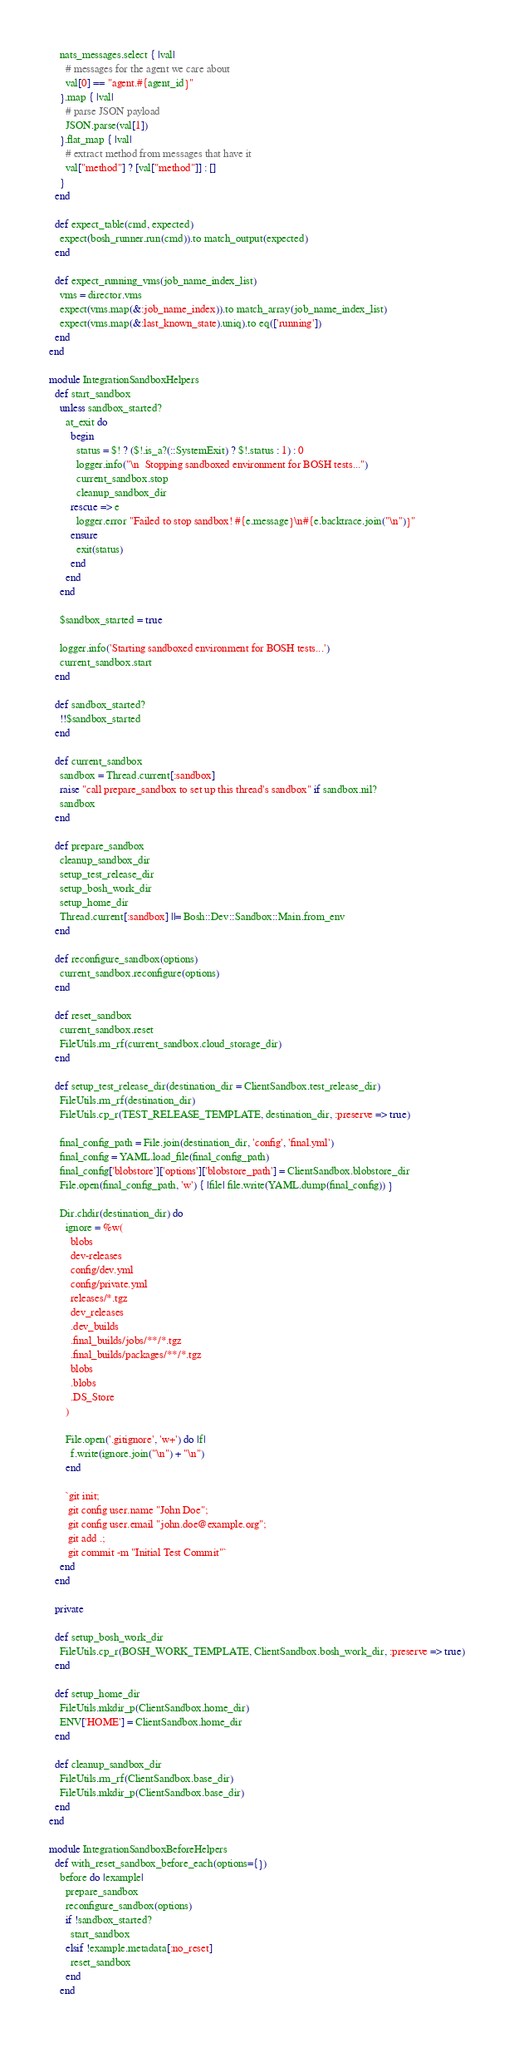Convert code to text. <code><loc_0><loc_0><loc_500><loc_500><_Ruby_>    nats_messages.select { |val|
      # messages for the agent we care about
      val[0] == "agent.#{agent_id}"
    }.map { |val|
      # parse JSON payload
      JSON.parse(val[1])
    }.flat_map { |val|
      # extract method from messages that have it
      val["method"] ? [val["method"]] : []
    }
  end

  def expect_table(cmd, expected)
    expect(bosh_runner.run(cmd)).to match_output(expected)
  end

  def expect_running_vms(job_name_index_list)
    vms = director.vms
    expect(vms.map(&:job_name_index)).to match_array(job_name_index_list)
    expect(vms.map(&:last_known_state).uniq).to eq(['running'])
  end
end

module IntegrationSandboxHelpers
  def start_sandbox
    unless sandbox_started?
      at_exit do
        begin
          status = $! ? ($!.is_a?(::SystemExit) ? $!.status : 1) : 0
          logger.info("\n  Stopping sandboxed environment for BOSH tests...")
          current_sandbox.stop
          cleanup_sandbox_dir
        rescue => e
          logger.error "Failed to stop sandbox! #{e.message}\n#{e.backtrace.join("\n")}"
        ensure
          exit(status)
        end
      end
    end

    $sandbox_started = true

    logger.info('Starting sandboxed environment for BOSH tests...')
    current_sandbox.start
  end

  def sandbox_started?
    !!$sandbox_started
  end

  def current_sandbox
    sandbox = Thread.current[:sandbox]
    raise "call prepare_sandbox to set up this thread's sandbox" if sandbox.nil?
    sandbox
  end

  def prepare_sandbox
    cleanup_sandbox_dir
    setup_test_release_dir
    setup_bosh_work_dir
    setup_home_dir
    Thread.current[:sandbox] ||= Bosh::Dev::Sandbox::Main.from_env
  end

  def reconfigure_sandbox(options)
    current_sandbox.reconfigure(options)
  end

  def reset_sandbox
    current_sandbox.reset
    FileUtils.rm_rf(current_sandbox.cloud_storage_dir)
  end

  def setup_test_release_dir(destination_dir = ClientSandbox.test_release_dir)
    FileUtils.rm_rf(destination_dir)
    FileUtils.cp_r(TEST_RELEASE_TEMPLATE, destination_dir, :preserve => true)

    final_config_path = File.join(destination_dir, 'config', 'final.yml')
    final_config = YAML.load_file(final_config_path)
    final_config['blobstore']['options']['blobstore_path'] = ClientSandbox.blobstore_dir
    File.open(final_config_path, 'w') { |file| file.write(YAML.dump(final_config)) }

    Dir.chdir(destination_dir) do
      ignore = %w(
        blobs
        dev-releases
        config/dev.yml
        config/private.yml
        releases/*.tgz
        dev_releases
        .dev_builds
        .final_builds/jobs/**/*.tgz
        .final_builds/packages/**/*.tgz
        blobs
        .blobs
        .DS_Store
      )

      File.open('.gitignore', 'w+') do |f|
        f.write(ignore.join("\n") + "\n")
      end

      `git init;
       git config user.name "John Doe";
       git config user.email "john.doe@example.org";
       git add .;
       git commit -m "Initial Test Commit"`
    end
  end

  private

  def setup_bosh_work_dir
    FileUtils.cp_r(BOSH_WORK_TEMPLATE, ClientSandbox.bosh_work_dir, :preserve => true)
  end

  def setup_home_dir
    FileUtils.mkdir_p(ClientSandbox.home_dir)
    ENV['HOME'] = ClientSandbox.home_dir
  end

  def cleanup_sandbox_dir
    FileUtils.rm_rf(ClientSandbox.base_dir)
    FileUtils.mkdir_p(ClientSandbox.base_dir)
  end
end

module IntegrationSandboxBeforeHelpers
  def with_reset_sandbox_before_each(options={})
    before do |example|
      prepare_sandbox
      reconfigure_sandbox(options)
      if !sandbox_started?
        start_sandbox
      elsif !example.metadata[:no_reset]
        reset_sandbox
      end
    end</code> 